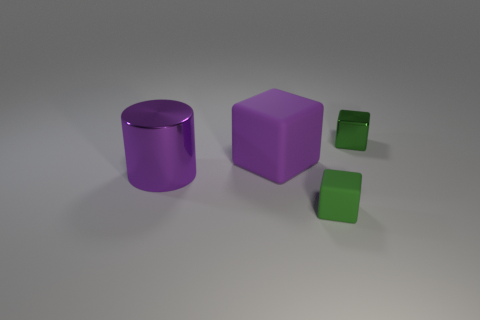Subtract all purple matte blocks. How many blocks are left? 2 Add 2 big brown balls. How many objects exist? 6 Subtract all purple blocks. How many blocks are left? 2 Subtract all yellow balls. How many green cubes are left? 2 Subtract all big yellow things. Subtract all large rubber things. How many objects are left? 3 Add 4 small green blocks. How many small green blocks are left? 6 Add 3 big brown rubber things. How many big brown rubber things exist? 3 Subtract 0 brown cylinders. How many objects are left? 4 Subtract all cylinders. How many objects are left? 3 Subtract 1 cylinders. How many cylinders are left? 0 